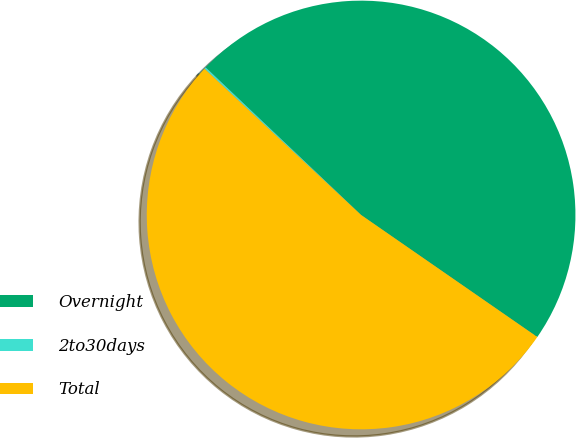Convert chart. <chart><loc_0><loc_0><loc_500><loc_500><pie_chart><fcel>Overnight<fcel>2to30days<fcel>Total<nl><fcel>47.55%<fcel>0.13%<fcel>52.31%<nl></chart> 